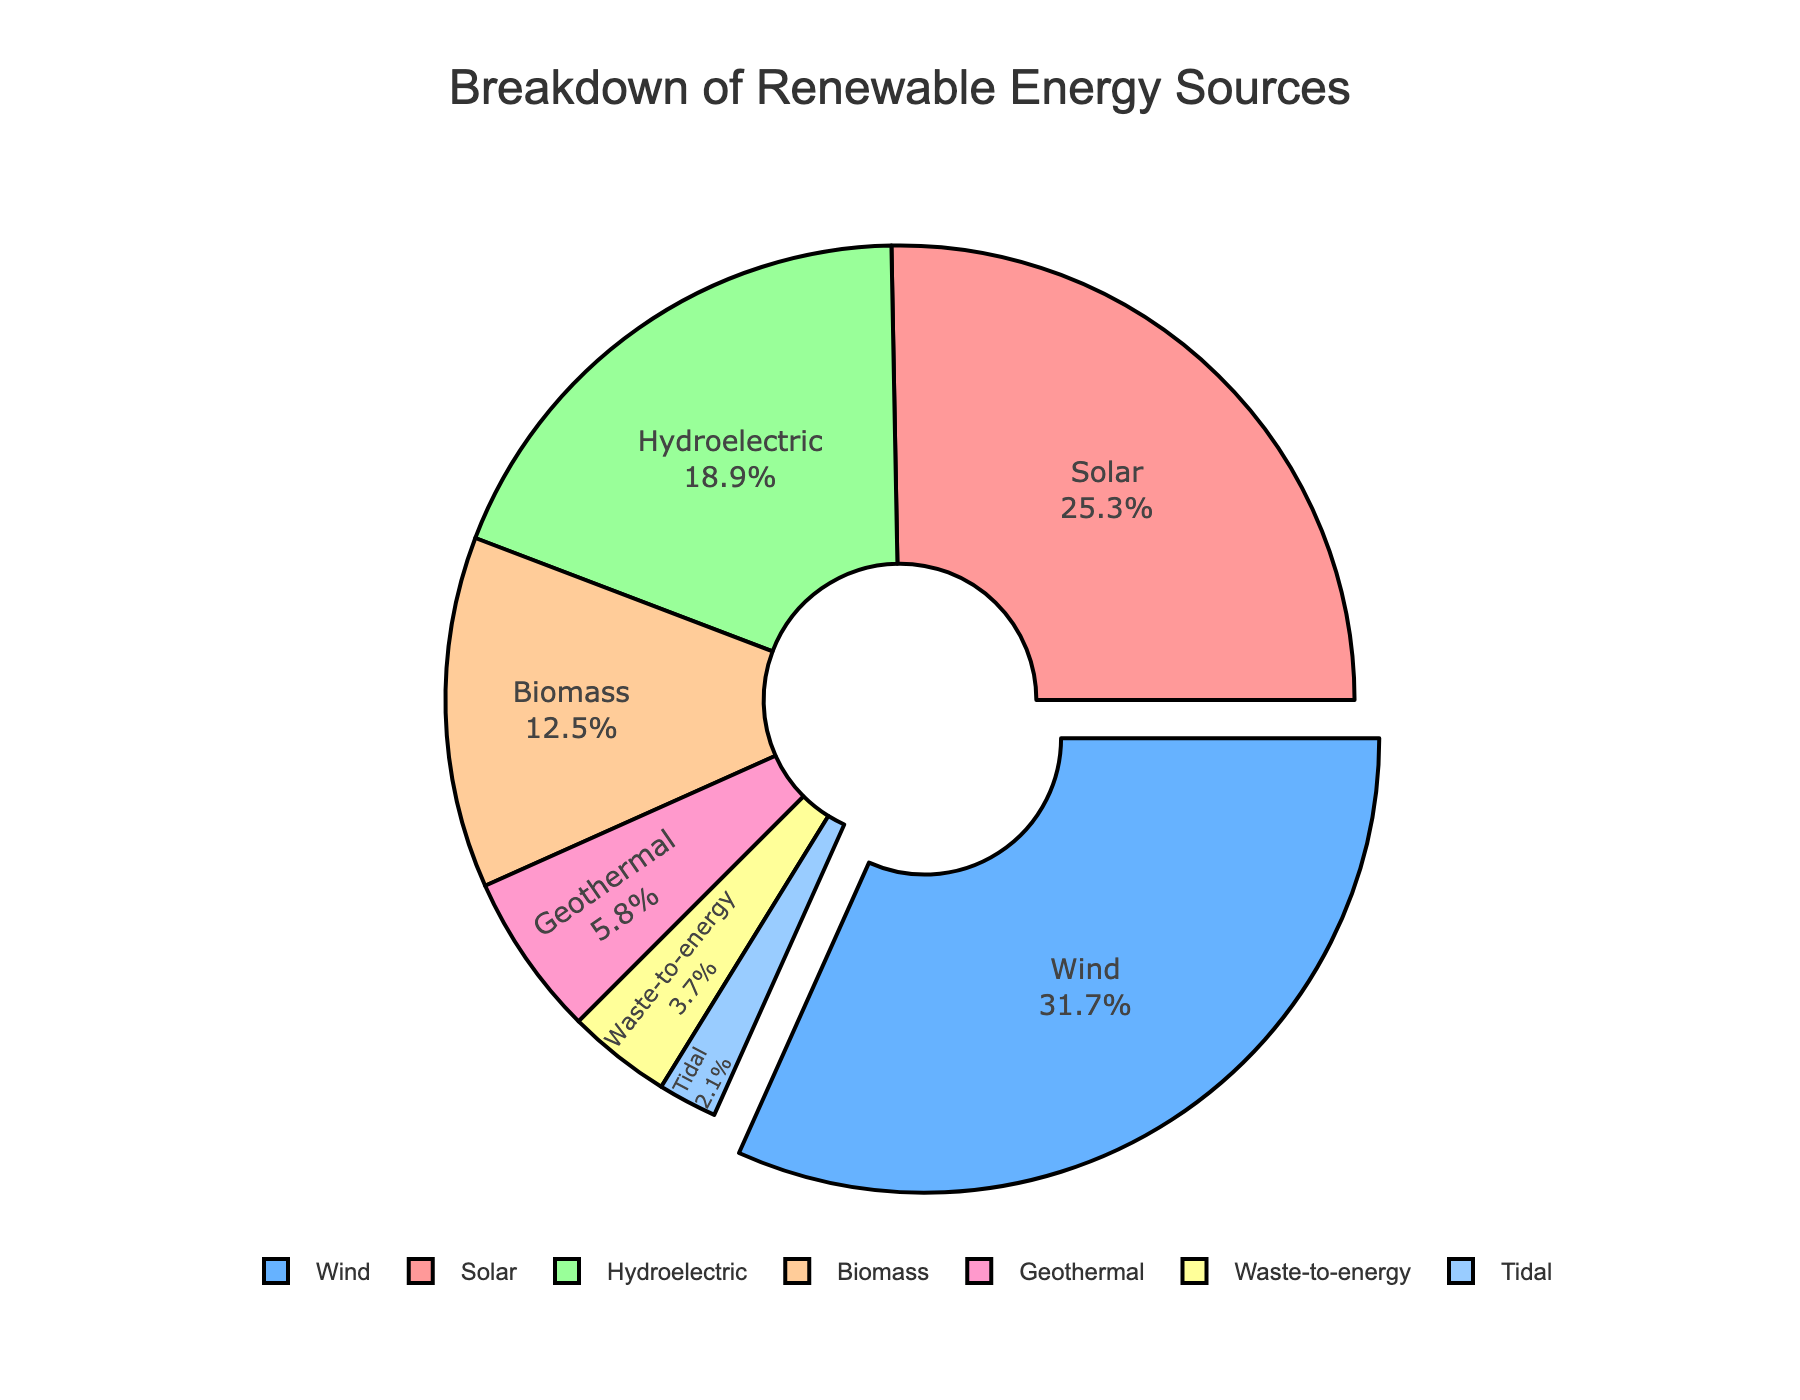Which renewable energy source contributes the most to the country's energy mix? The energy source with the highest percentage value contributes the most. According to the pie chart, wind energy has the highest percentage at 31.7%.
Answer: Wind What percentage of the total energy mix is composed of solar and hydroelectric power combined? Sum the percentages of solar (25.3%) and hydroelectric (18.9%) from the chart: 25.3 + 18.9 = 44.2%.
Answer: 44.2% How much more does wind contribute compared to biomass? Subtract the percentage of biomass (12.5%) from wind (31.7%): 31.7 - 12.5 = 19.2%.
Answer: 19.2% Does solar energy contribute more or less than hydroelectric plus biomass combined? First, sum the percentages of hydroelectric (18.9%) and biomass (12.5%): 18.9 + 12.5 = 31.4. Then, compare it with solar energy (25.3%). Solar (25.3%) is less than hydroelectric plus biomass (31.4%).
Answer: Less Which renewable energy source has the smallest contribution, and what is its percentage? The smallest percentage on the pie chart represents the energy source with the least contribution. Tidal energy has the smallest percentage at 2.1%.
Answer: Tidal, 2.1% What is the combined percentage of geothermal and waste-to-energy sources in the country's energy mix? Sum the percentage values of geothermal (5.8%) and waste-to-energy (3.7%): 5.8 + 3.7 = 9.5%.
Answer: 9.5% What color on the chart represents wind energy? The chart uses colors to represent different energy sources. Wind energy is represented by a blue color.
Answer: Blue How many energy sources contribute less than 10% each to the total energy mix? Identify each energy source with a percentage less than 10% on the pie chart: Geothermal (5.8%), Tidal (2.1%), Waste-to-energy (3.7%). There are 3 sources.
Answer: 3 If tidal and waste-to-energy sources were combined into one category, what percentage would this new category represent? Sum the percentages of tidal (2.1%) and waste-to-energy (3.7%): 2.1 + 3.7 = 5.8%.
Answer: 5.8% What portion of the pie chart is "pulled out," and why? The portion of the pie chart that is "pulled out" is wind energy, which has the highest percentage at 31.7%. This visual effect highlights the dominant contribution of wind energy.
Answer: Wind energy, to highlight its dominance 